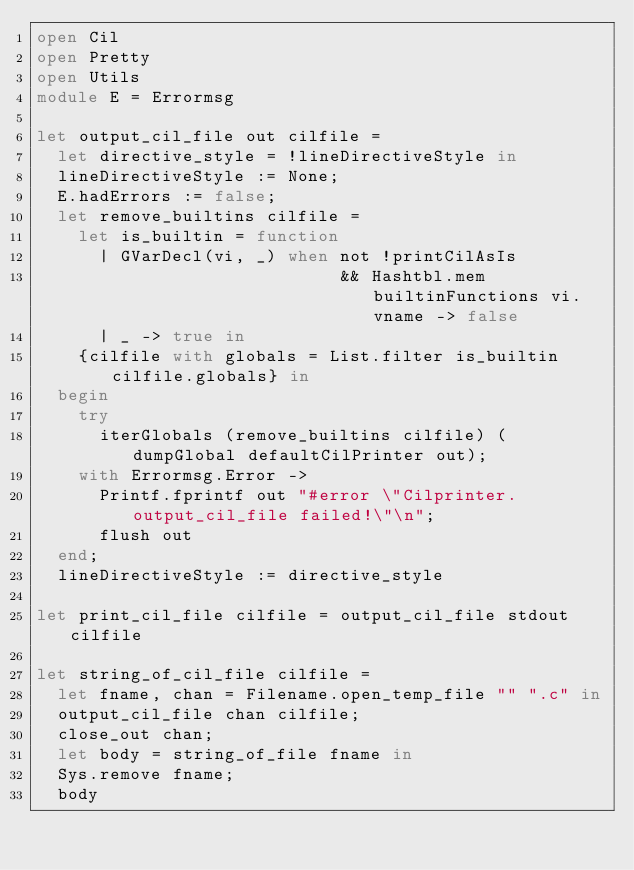<code> <loc_0><loc_0><loc_500><loc_500><_OCaml_>open Cil
open Pretty
open Utils
module E = Errormsg

let output_cil_file out cilfile =
  let directive_style = !lineDirectiveStyle in
  lineDirectiveStyle := None;
  E.hadErrors := false;
  let remove_builtins cilfile =
    let is_builtin = function
      | GVarDecl(vi, _) when not !printCilAsIs
                             && Hashtbl.mem builtinFunctions vi.vname -> false
      | _ -> true in
    {cilfile with globals = List.filter is_builtin cilfile.globals} in
  begin
    try
      iterGlobals (remove_builtins cilfile) (dumpGlobal defaultCilPrinter out);
    with Errormsg.Error ->
      Printf.fprintf out "#error \"Cilprinter.output_cil_file failed!\"\n";
      flush out
  end;
  lineDirectiveStyle := directive_style

let print_cil_file cilfile = output_cil_file stdout cilfile

let string_of_cil_file cilfile =
  let fname, chan = Filename.open_temp_file "" ".c" in
  output_cil_file chan cilfile;
  close_out chan;
  let body = string_of_file fname in
  Sys.remove fname;
  body
</code> 